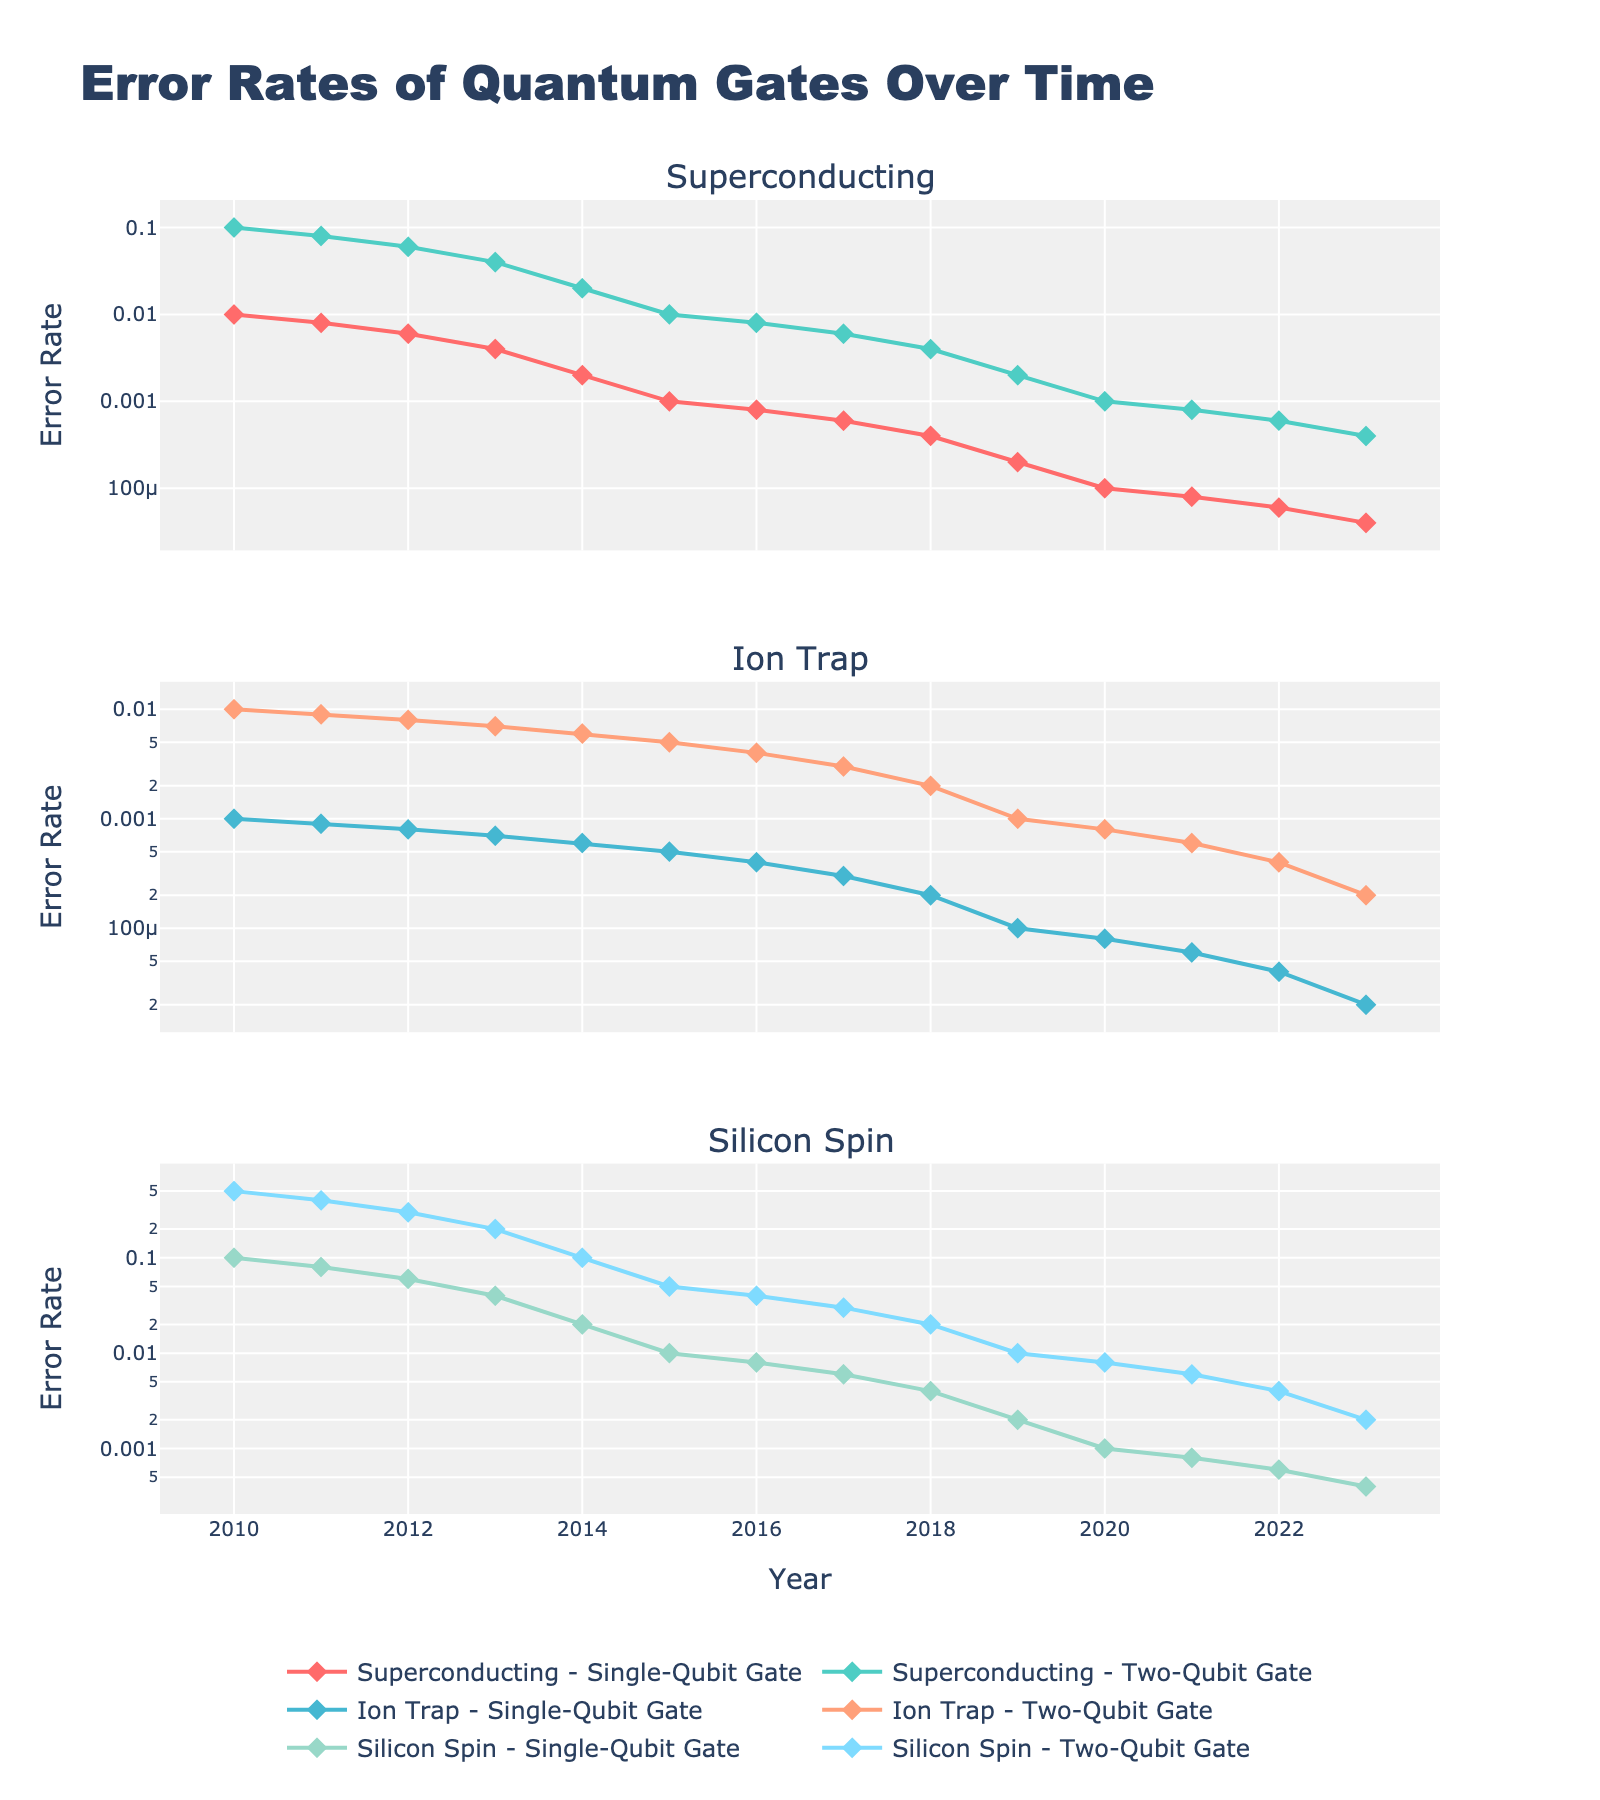What trend do we observe in the error rates of single-qubit gates for superconducting technology from 2010 to 2023? The figure shows a declining trend in the error rates of single-qubit gates for superconducting technology. From 2010 to 2023, the error rates decrease from 0.01 to 0.00004. This shows continuous improvement over the years.
Answer: Declining trend How do the error rates of two-qubit gates for ion trap technology in 2019 compare to those in 2021? In 2019, the error rate for two-qubit gates in ion trap technology is 0.001, while in 2021, it is 0.0006. The error rate in 2021 is lower than in 2019.
Answer: Lower in 2021 Is there any year where single-qubit gate error rates for superconducting technology were better than those for silicon spin technology? If so, which year? We need to compare the single-qubit gate error rates for superconducting and silicon spin technology each year. In 2015, we observe that the error rate for superconducting is 0.001, and for silicon spin, it is 0.01. Thus, superconducting technology had better error rates in 2015.
Answer: 2015 Which quantum gate type and technology had the highest error rate in 2010? By looking at the error rates for each technology and gate in 2010, the highest error rate is observed for two-qubit gates in silicon spin technology, which is 0.5.
Answer: Two-qubit gate, silicon spin Calculate the average error rate for ion trap single-qubit gates from 2015 to 2023. We sum the error rates for ion trap single-qubit gates from 2015 (0.0005) to 2023 (0.00002), resulting in a total of 0.0038. Then, we divide by the number of years (2023 - 2015 + 1 = 9) to get the average: \( 0.0038 / 9 \approx 0.000422 \).
Answer: 0.000422 In which year did silicon spin technology's single-qubit gate error rate drop below 0.01? Investigating the data for single-qubit gates from silicon spin technology, the error rate dropped below 0.01 starting in 2015, where it reached 0.008.
Answer: 2015 Compare the color and marker symbol used for superconducting single-qubit gates and ion trap two-qubit gates. The figure shows that superconducting single-qubit gates are represented with a red line and diamond markers, whereas ion trap two-qubit gates are represented with a cyan line and diamond markers as well.
Answer: Red with diamond markers for superconducting single-qubit gates, cyan with diamond markers for ion trap two-qubit gates 